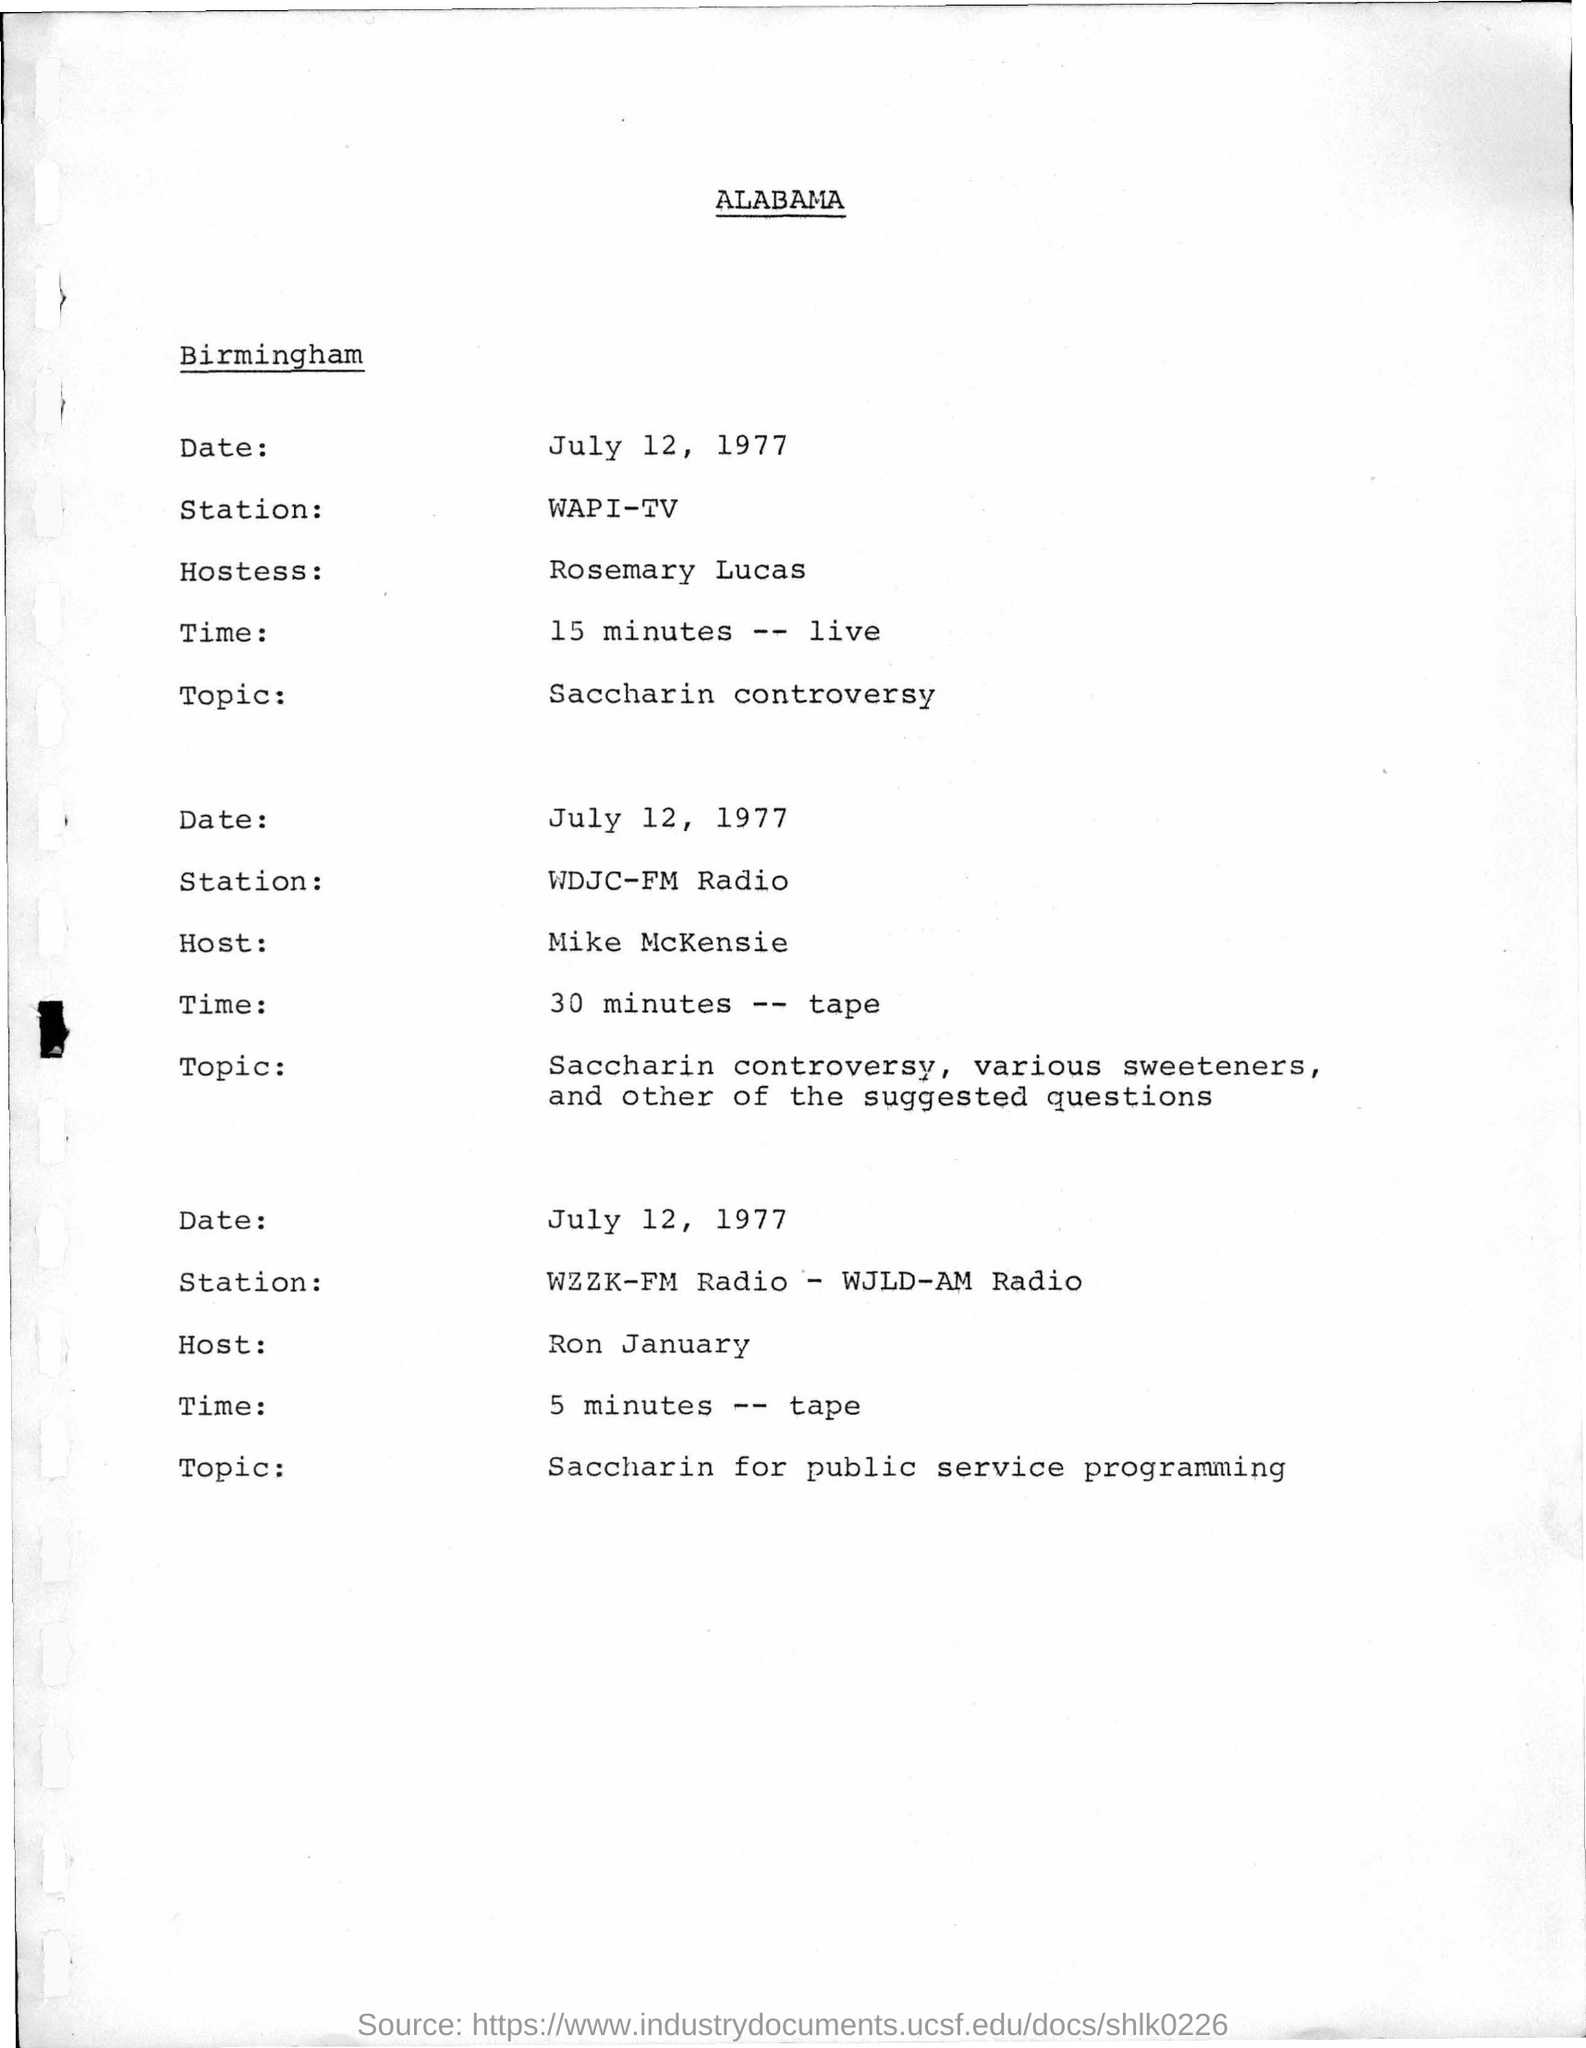Who is the Host for the Saccharin for Public Service Programming?
Provide a succinct answer. RON JANUARY. Who is the Hostess at WAPI-TV live programme?
Your answer should be compact. ROSEMARY LUCAS. 